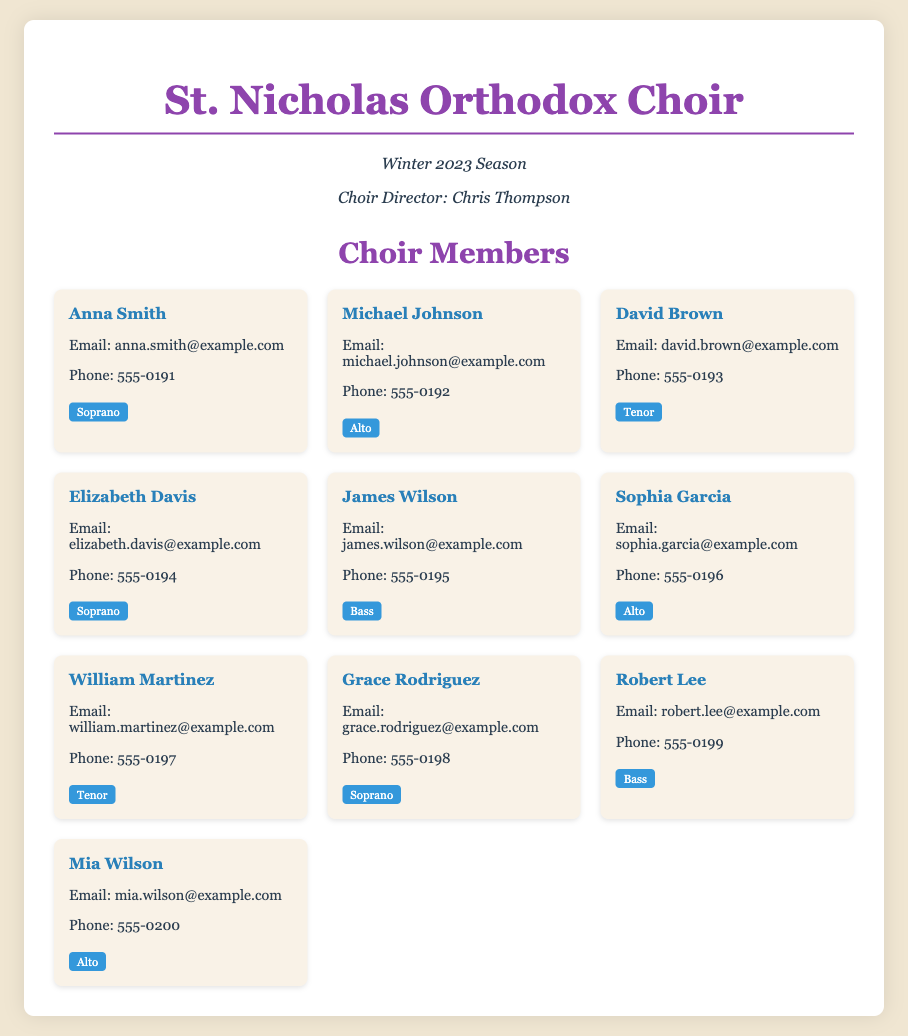What is the name of the choir director? The document states the choir director is Chris Thompson.
Answer: Chris Thompson How many Alto members are listed? The document lists three members assigned as Alto: Michael Johnson, Sophia Garcia, and Mia Wilson.
Answer: 3 What vocal part is assigned to David Brown? The member card for David Brown specifies that he is assigned as Tenor.
Answer: Tenor Which member has the email address "anna.smith@example.com"? The document indicates that Anna Smith is the member with the listed email address.
Answer: Anna Smith What is the phone number of James Wilson? According to the document, James Wilson's phone number is 555-0195.
Answer: 555-0195 Who are the Soprano members in the choir? The information shows that Anna Smith, Elizabeth Davis, and Grace Rodriguez are assigned as Soprano.
Answer: Anna Smith, Elizabeth Davis, Grace Rodriguez What is the total number of choir members listed? The document includes ten members in total within the list.
Answer: 10 What is the background color of the document? The document's style specifies a background color of #f0e6d2.
Answer: #f0e6d2 